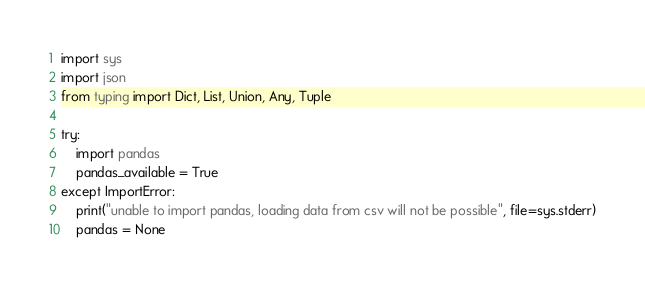<code> <loc_0><loc_0><loc_500><loc_500><_Python_>import sys
import json
from typing import Dict, List, Union, Any, Tuple

try:
    import pandas
    pandas_available = True
except ImportError:
    print("unable to import pandas, loading data from csv will not be possible", file=sys.stderr)
    pandas = None</code> 